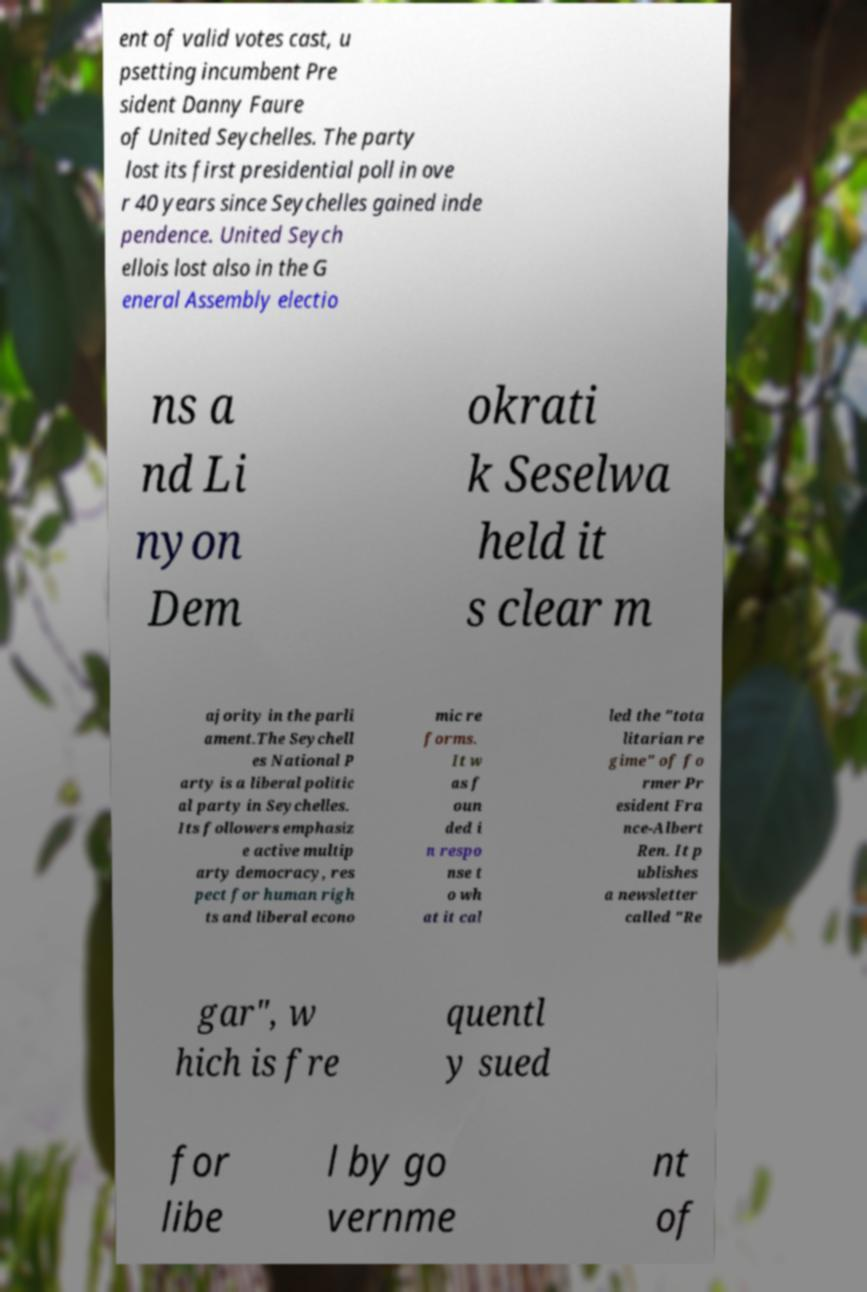Please identify and transcribe the text found in this image. ent of valid votes cast, u psetting incumbent Pre sident Danny Faure of United Seychelles. The party lost its first presidential poll in ove r 40 years since Seychelles gained inde pendence. United Seych ellois lost also in the G eneral Assembly electio ns a nd Li nyon Dem okrati k Seselwa held it s clear m ajority in the parli ament.The Seychell es National P arty is a liberal politic al party in Seychelles. Its followers emphasiz e active multip arty democracy, res pect for human righ ts and liberal econo mic re forms. It w as f oun ded i n respo nse t o wh at it cal led the "tota litarian re gime" of fo rmer Pr esident Fra nce-Albert Ren. It p ublishes a newsletter called "Re gar", w hich is fre quentl y sued for libe l by go vernme nt of 